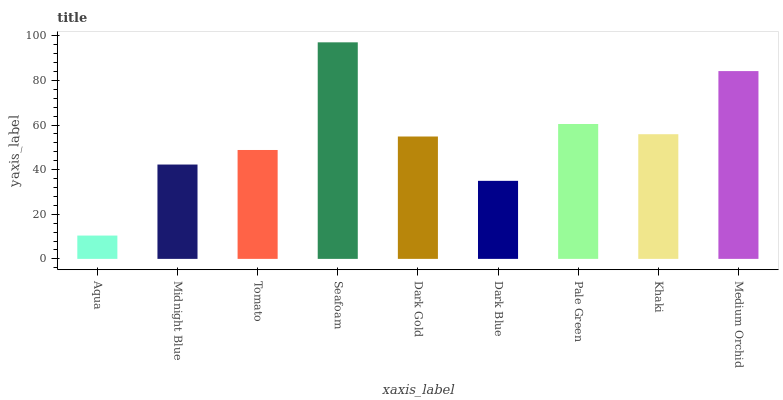Is Midnight Blue the minimum?
Answer yes or no. No. Is Midnight Blue the maximum?
Answer yes or no. No. Is Midnight Blue greater than Aqua?
Answer yes or no. Yes. Is Aqua less than Midnight Blue?
Answer yes or no. Yes. Is Aqua greater than Midnight Blue?
Answer yes or no. No. Is Midnight Blue less than Aqua?
Answer yes or no. No. Is Dark Gold the high median?
Answer yes or no. Yes. Is Dark Gold the low median?
Answer yes or no. Yes. Is Medium Orchid the high median?
Answer yes or no. No. Is Khaki the low median?
Answer yes or no. No. 